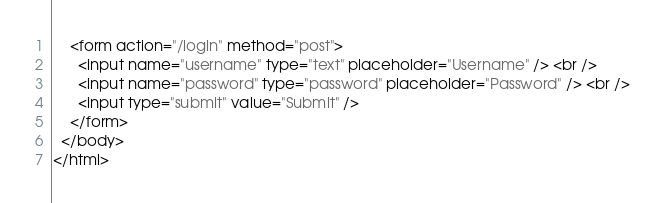Convert code to text. <code><loc_0><loc_0><loc_500><loc_500><_HTML_>    <form action="/login" method="post">
      <input name="username" type="text" placeholder="Username" /> <br />
      <input name="password" type="password" placeholder="Password" /> <br />
      <input type="submit" value="Submit" />
    </form>
  </body>
</html>
</code> 